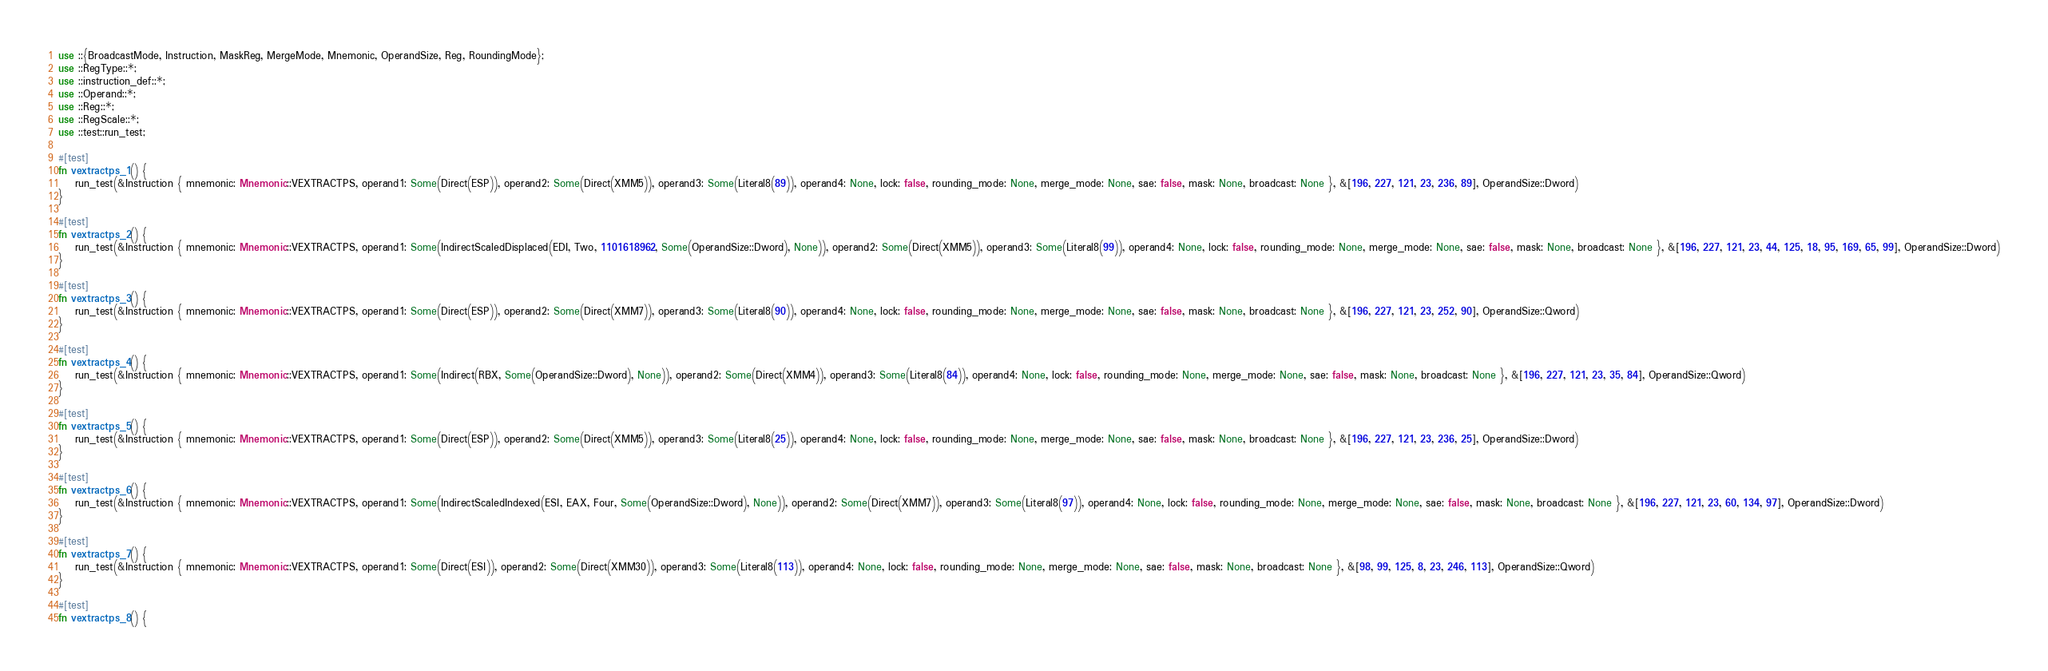Convert code to text. <code><loc_0><loc_0><loc_500><loc_500><_Rust_>use ::{BroadcastMode, Instruction, MaskReg, MergeMode, Mnemonic, OperandSize, Reg, RoundingMode};
use ::RegType::*;
use ::instruction_def::*;
use ::Operand::*;
use ::Reg::*;
use ::RegScale::*;
use ::test::run_test;

#[test]
fn vextractps_1() {
    run_test(&Instruction { mnemonic: Mnemonic::VEXTRACTPS, operand1: Some(Direct(ESP)), operand2: Some(Direct(XMM5)), operand3: Some(Literal8(89)), operand4: None, lock: false, rounding_mode: None, merge_mode: None, sae: false, mask: None, broadcast: None }, &[196, 227, 121, 23, 236, 89], OperandSize::Dword)
}

#[test]
fn vextractps_2() {
    run_test(&Instruction { mnemonic: Mnemonic::VEXTRACTPS, operand1: Some(IndirectScaledDisplaced(EDI, Two, 1101618962, Some(OperandSize::Dword), None)), operand2: Some(Direct(XMM5)), operand3: Some(Literal8(99)), operand4: None, lock: false, rounding_mode: None, merge_mode: None, sae: false, mask: None, broadcast: None }, &[196, 227, 121, 23, 44, 125, 18, 95, 169, 65, 99], OperandSize::Dword)
}

#[test]
fn vextractps_3() {
    run_test(&Instruction { mnemonic: Mnemonic::VEXTRACTPS, operand1: Some(Direct(ESP)), operand2: Some(Direct(XMM7)), operand3: Some(Literal8(90)), operand4: None, lock: false, rounding_mode: None, merge_mode: None, sae: false, mask: None, broadcast: None }, &[196, 227, 121, 23, 252, 90], OperandSize::Qword)
}

#[test]
fn vextractps_4() {
    run_test(&Instruction { mnemonic: Mnemonic::VEXTRACTPS, operand1: Some(Indirect(RBX, Some(OperandSize::Dword), None)), operand2: Some(Direct(XMM4)), operand3: Some(Literal8(84)), operand4: None, lock: false, rounding_mode: None, merge_mode: None, sae: false, mask: None, broadcast: None }, &[196, 227, 121, 23, 35, 84], OperandSize::Qword)
}

#[test]
fn vextractps_5() {
    run_test(&Instruction { mnemonic: Mnemonic::VEXTRACTPS, operand1: Some(Direct(ESP)), operand2: Some(Direct(XMM5)), operand3: Some(Literal8(25)), operand4: None, lock: false, rounding_mode: None, merge_mode: None, sae: false, mask: None, broadcast: None }, &[196, 227, 121, 23, 236, 25], OperandSize::Dword)
}

#[test]
fn vextractps_6() {
    run_test(&Instruction { mnemonic: Mnemonic::VEXTRACTPS, operand1: Some(IndirectScaledIndexed(ESI, EAX, Four, Some(OperandSize::Dword), None)), operand2: Some(Direct(XMM7)), operand3: Some(Literal8(97)), operand4: None, lock: false, rounding_mode: None, merge_mode: None, sae: false, mask: None, broadcast: None }, &[196, 227, 121, 23, 60, 134, 97], OperandSize::Dword)
}

#[test]
fn vextractps_7() {
    run_test(&Instruction { mnemonic: Mnemonic::VEXTRACTPS, operand1: Some(Direct(ESI)), operand2: Some(Direct(XMM30)), operand3: Some(Literal8(113)), operand4: None, lock: false, rounding_mode: None, merge_mode: None, sae: false, mask: None, broadcast: None }, &[98, 99, 125, 8, 23, 246, 113], OperandSize::Qword)
}

#[test]
fn vextractps_8() {</code> 